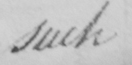What does this handwritten line say? such 